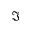Convert formula to latex. <formula><loc_0><loc_0><loc_500><loc_500>\Im</formula> 